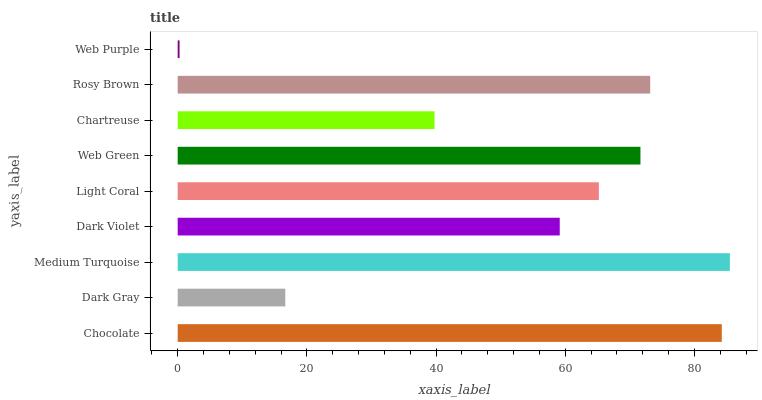Is Web Purple the minimum?
Answer yes or no. Yes. Is Medium Turquoise the maximum?
Answer yes or no. Yes. Is Dark Gray the minimum?
Answer yes or no. No. Is Dark Gray the maximum?
Answer yes or no. No. Is Chocolate greater than Dark Gray?
Answer yes or no. Yes. Is Dark Gray less than Chocolate?
Answer yes or no. Yes. Is Dark Gray greater than Chocolate?
Answer yes or no. No. Is Chocolate less than Dark Gray?
Answer yes or no. No. Is Light Coral the high median?
Answer yes or no. Yes. Is Light Coral the low median?
Answer yes or no. Yes. Is Rosy Brown the high median?
Answer yes or no. No. Is Web Green the low median?
Answer yes or no. No. 